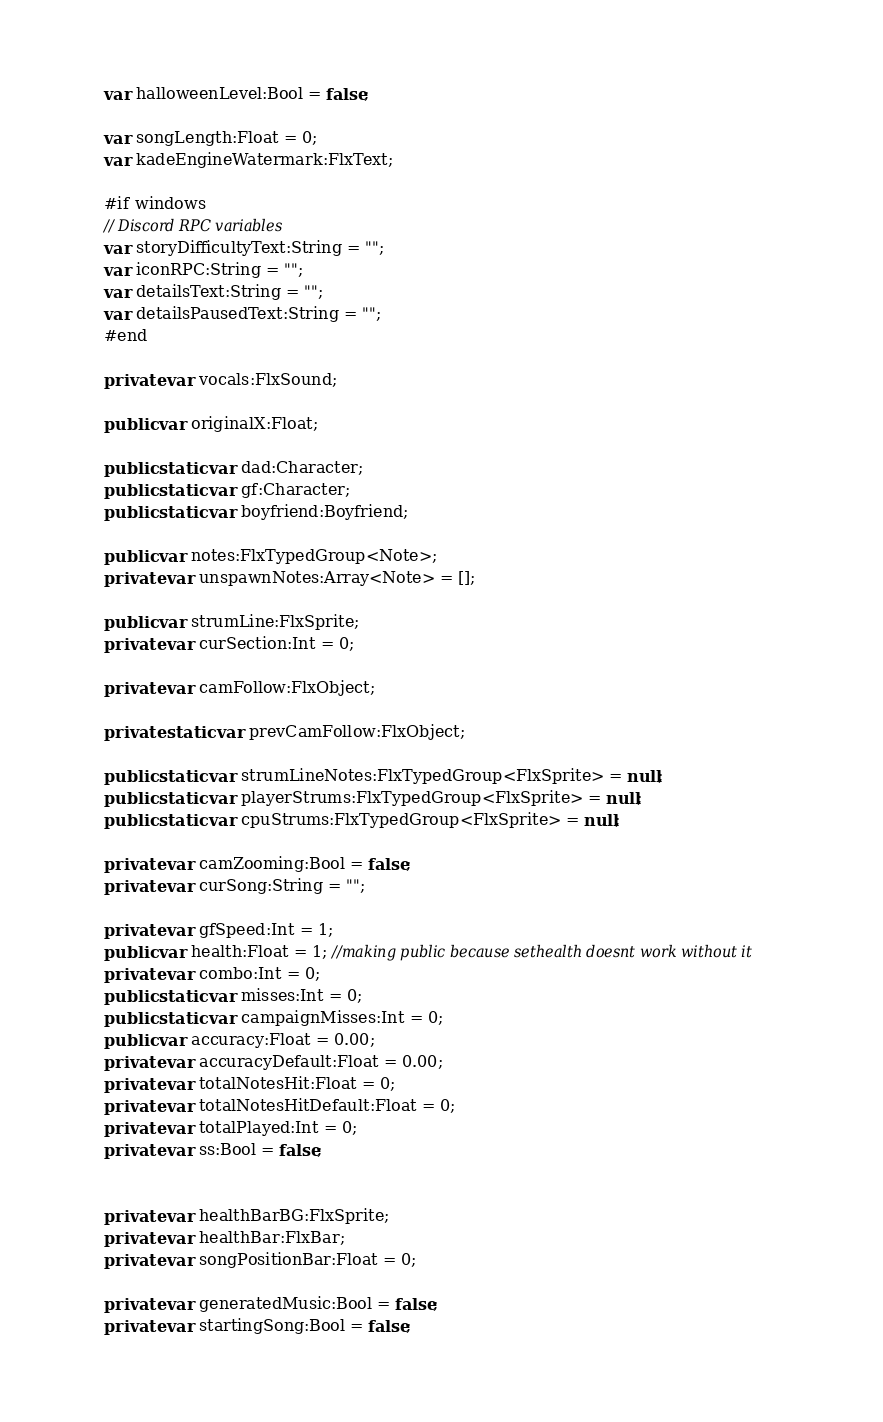<code> <loc_0><loc_0><loc_500><loc_500><_Haxe_>
	var halloweenLevel:Bool = false;

	var songLength:Float = 0;
	var kadeEngineWatermark:FlxText;
	
	#if windows
	// Discord RPC variables
	var storyDifficultyText:String = "";
	var iconRPC:String = "";
	var detailsText:String = "";
	var detailsPausedText:String = "";
	#end

	private var vocals:FlxSound;

	public var originalX:Float;

	public static var dad:Character;
	public static var gf:Character;
	public static var boyfriend:Boyfriend;

	public var notes:FlxTypedGroup<Note>;
	private var unspawnNotes:Array<Note> = [];

	public var strumLine:FlxSprite;
	private var curSection:Int = 0;

	private var camFollow:FlxObject;

	private static var prevCamFollow:FlxObject;

	public static var strumLineNotes:FlxTypedGroup<FlxSprite> = null;
	public static var playerStrums:FlxTypedGroup<FlxSprite> = null;
	public static var cpuStrums:FlxTypedGroup<FlxSprite> = null;

	private var camZooming:Bool = false;
	private var curSong:String = "";

	private var gfSpeed:Int = 1;
	public var health:Float = 1; //making public because sethealth doesnt work without it
	private var combo:Int = 0;
	public static var misses:Int = 0;
	public static var campaignMisses:Int = 0;
	public var accuracy:Float = 0.00;
	private var accuracyDefault:Float = 0.00;
	private var totalNotesHit:Float = 0;
	private var totalNotesHitDefault:Float = 0;
	private var totalPlayed:Int = 0;
	private var ss:Bool = false;


	private var healthBarBG:FlxSprite;
	private var healthBar:FlxBar;
	private var songPositionBar:Float = 0;
	
	private var generatedMusic:Bool = false;
	private var startingSong:Bool = false;
</code> 